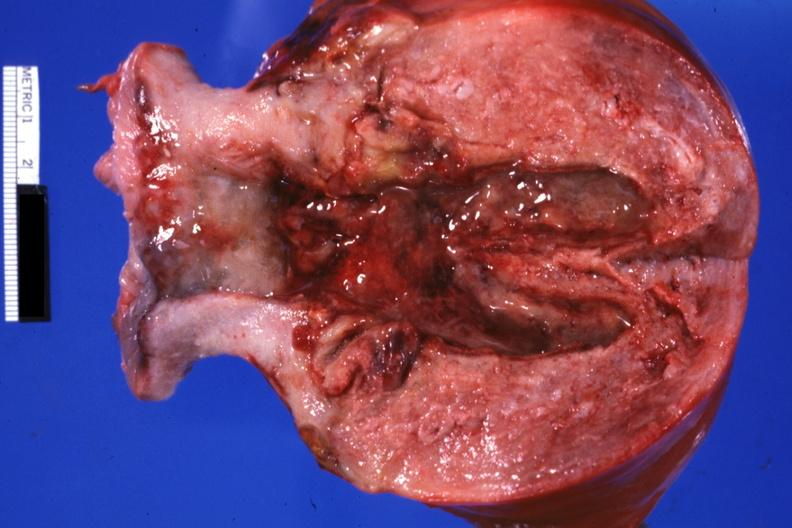what is present?
Answer the question using a single word or phrase. Uterus 